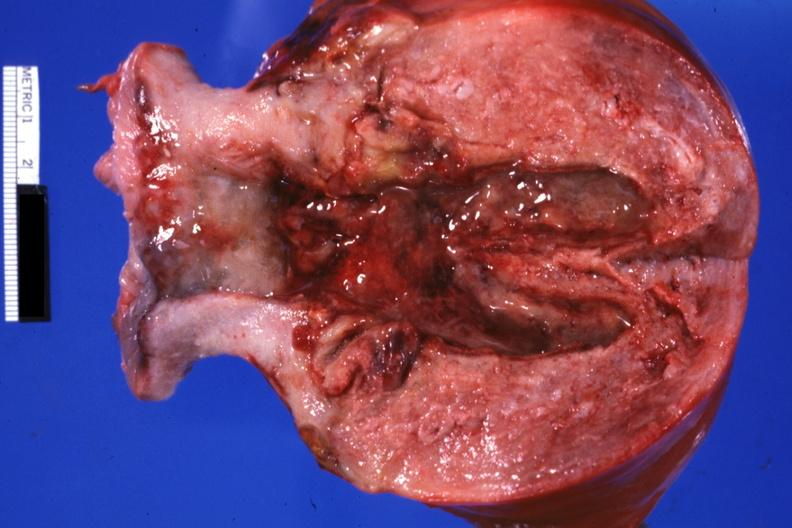what is present?
Answer the question using a single word or phrase. Uterus 